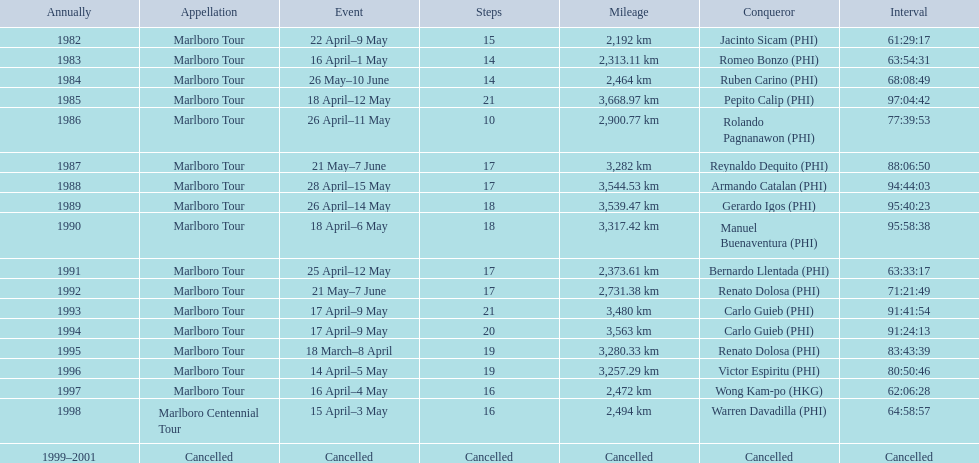Who were all of the winners? Jacinto Sicam (PHI), Romeo Bonzo (PHI), Ruben Carino (PHI), Pepito Calip (PHI), Rolando Pagnanawon (PHI), Reynaldo Dequito (PHI), Armando Catalan (PHI), Gerardo Igos (PHI), Manuel Buenaventura (PHI), Bernardo Llentada (PHI), Renato Dolosa (PHI), Carlo Guieb (PHI), Carlo Guieb (PHI), Renato Dolosa (PHI), Victor Espiritu (PHI), Wong Kam-po (HKG), Warren Davadilla (PHI), Cancelled. When did they compete? 1982, 1983, 1984, 1985, 1986, 1987, 1988, 1989, 1990, 1991, 1992, 1993, 1994, 1995, 1996, 1997, 1998, 1999–2001. What were their finishing times? 61:29:17, 63:54:31, 68:08:49, 97:04:42, 77:39:53, 88:06:50, 94:44:03, 95:40:23, 95:58:38, 63:33:17, 71:21:49, 91:41:54, 91:24:13, 83:43:39, 80:50:46, 62:06:28, 64:58:57, Cancelled. And who won during 1998? Warren Davadilla (PHI). What was his time? 64:58:57. 